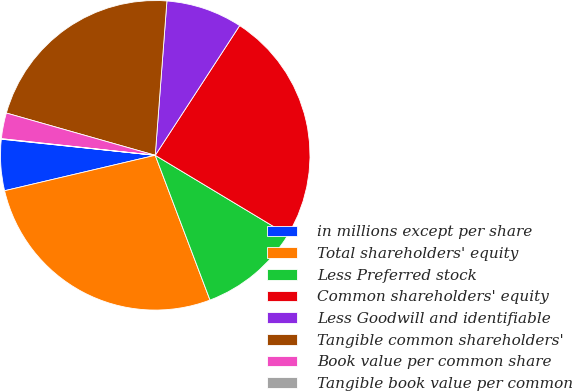<chart> <loc_0><loc_0><loc_500><loc_500><pie_chart><fcel>in millions except per share<fcel>Total shareholders' equity<fcel>Less Preferred stock<fcel>Common shareholders' equity<fcel>Less Goodwill and identifiable<fcel>Tangible common shareholders'<fcel>Book value per common share<fcel>Tangible book value per common<nl><fcel>5.34%<fcel>27.08%<fcel>10.62%<fcel>24.44%<fcel>7.98%<fcel>21.8%<fcel>2.69%<fcel>0.05%<nl></chart> 